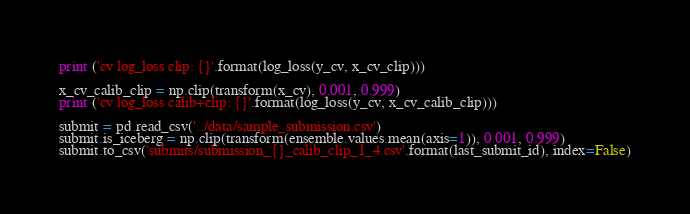<code> <loc_0><loc_0><loc_500><loc_500><_Python_>print ('cv log_loss clip: {}'.format(log_loss(y_cv, x_cv_clip)))

x_cv_calib_clip = np.clip(transform(x_cv), 0.001, 0.999)
print ('cv log_loss calib+clip: {}'.format(log_loss(y_cv, x_cv_calib_clip)))

submit = pd.read_csv('../data/sample_submission.csv')
submit.is_iceberg = np.clip(transform(ensemble.values.mean(axis=1)), 0.001, 0.999)
submit.to_csv('submits/submission_{}_calib_clip_1_4.csv'.format(last_submit_id), index=False)

</code> 